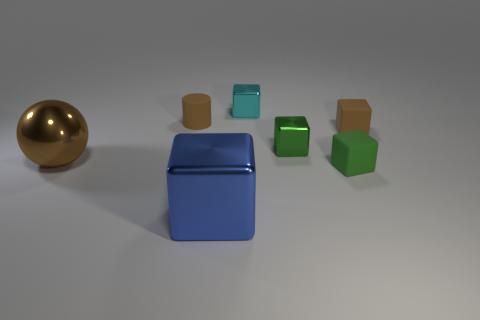There is a rubber thing that is in front of the big brown object; does it have the same shape as the cyan object?
Your answer should be compact. Yes. Are there fewer big cyan cubes than tiny brown things?
Your answer should be compact. Yes. What number of tiny shiny things are the same color as the tiny cylinder?
Ensure brevity in your answer.  0. There is a big thing that is the same color as the small matte cylinder; what material is it?
Make the answer very short. Metal. There is a metallic sphere; is it the same color as the rubber object on the left side of the small cyan object?
Give a very brief answer. Yes. Is the number of large yellow metal cubes greater than the number of cyan cubes?
Offer a very short reply. No. There is a brown thing that is the same shape as the small cyan metal thing; what is its size?
Your answer should be compact. Small. Are the large blue thing and the green block that is to the right of the tiny green shiny thing made of the same material?
Your response must be concise. No. What number of objects are either tiny cyan metal blocks or large cyan balls?
Ensure brevity in your answer.  1. Do the matte thing that is in front of the brown shiny thing and the brown rubber thing that is on the right side of the blue shiny object have the same size?
Provide a succinct answer. Yes. 